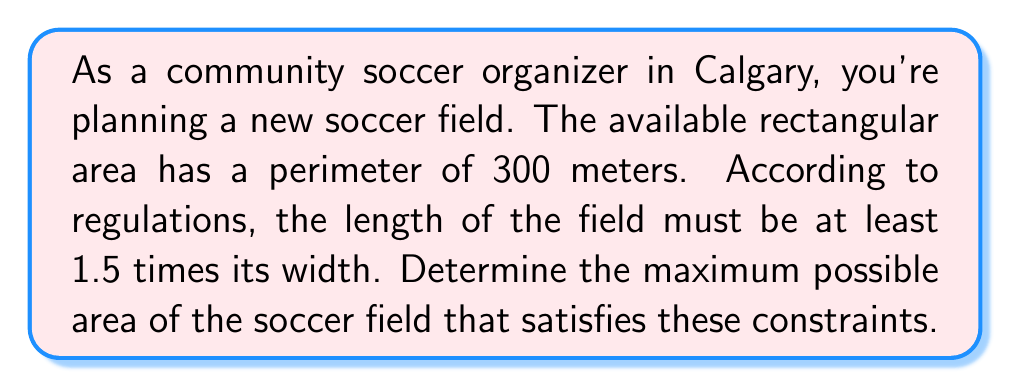Could you help me with this problem? Let's approach this step-by-step:

1) Let $w$ represent the width of the field and $l$ represent the length.

2) Given that the perimeter is 300 meters, we can write:
   $$2w + 2l = 300$$
   $$w + l = 150$$ ... (1)

3) The constraint that the length must be at least 1.5 times the width can be expressed as:
   $$l \geq 1.5w$$ ... (2)

4) To maximize the area, we'll assume equality in (2):
   $$l = 1.5w$$ ... (3)

5) Substituting (3) into (1):
   $$w + 1.5w = 150$$
   $$2.5w = 150$$
   $$w = 60$$

6) Using (3) again:
   $$l = 1.5(60) = 90$$

7) Now we can calculate the maximum area:
   $$A = w \times l = 60 \times 90 = 5400$$

8) To verify the perimeter constraint:
   $$2w + 2l = 2(60) + 2(90) = 120 + 180 = 300$$

Therefore, the maximum area is achieved when the width is 60 meters and the length is 90 meters.
Answer: The maximum possible area of the soccer field is $5400$ square meters, with dimensions of $60$ meters wide by $90$ meters long. 